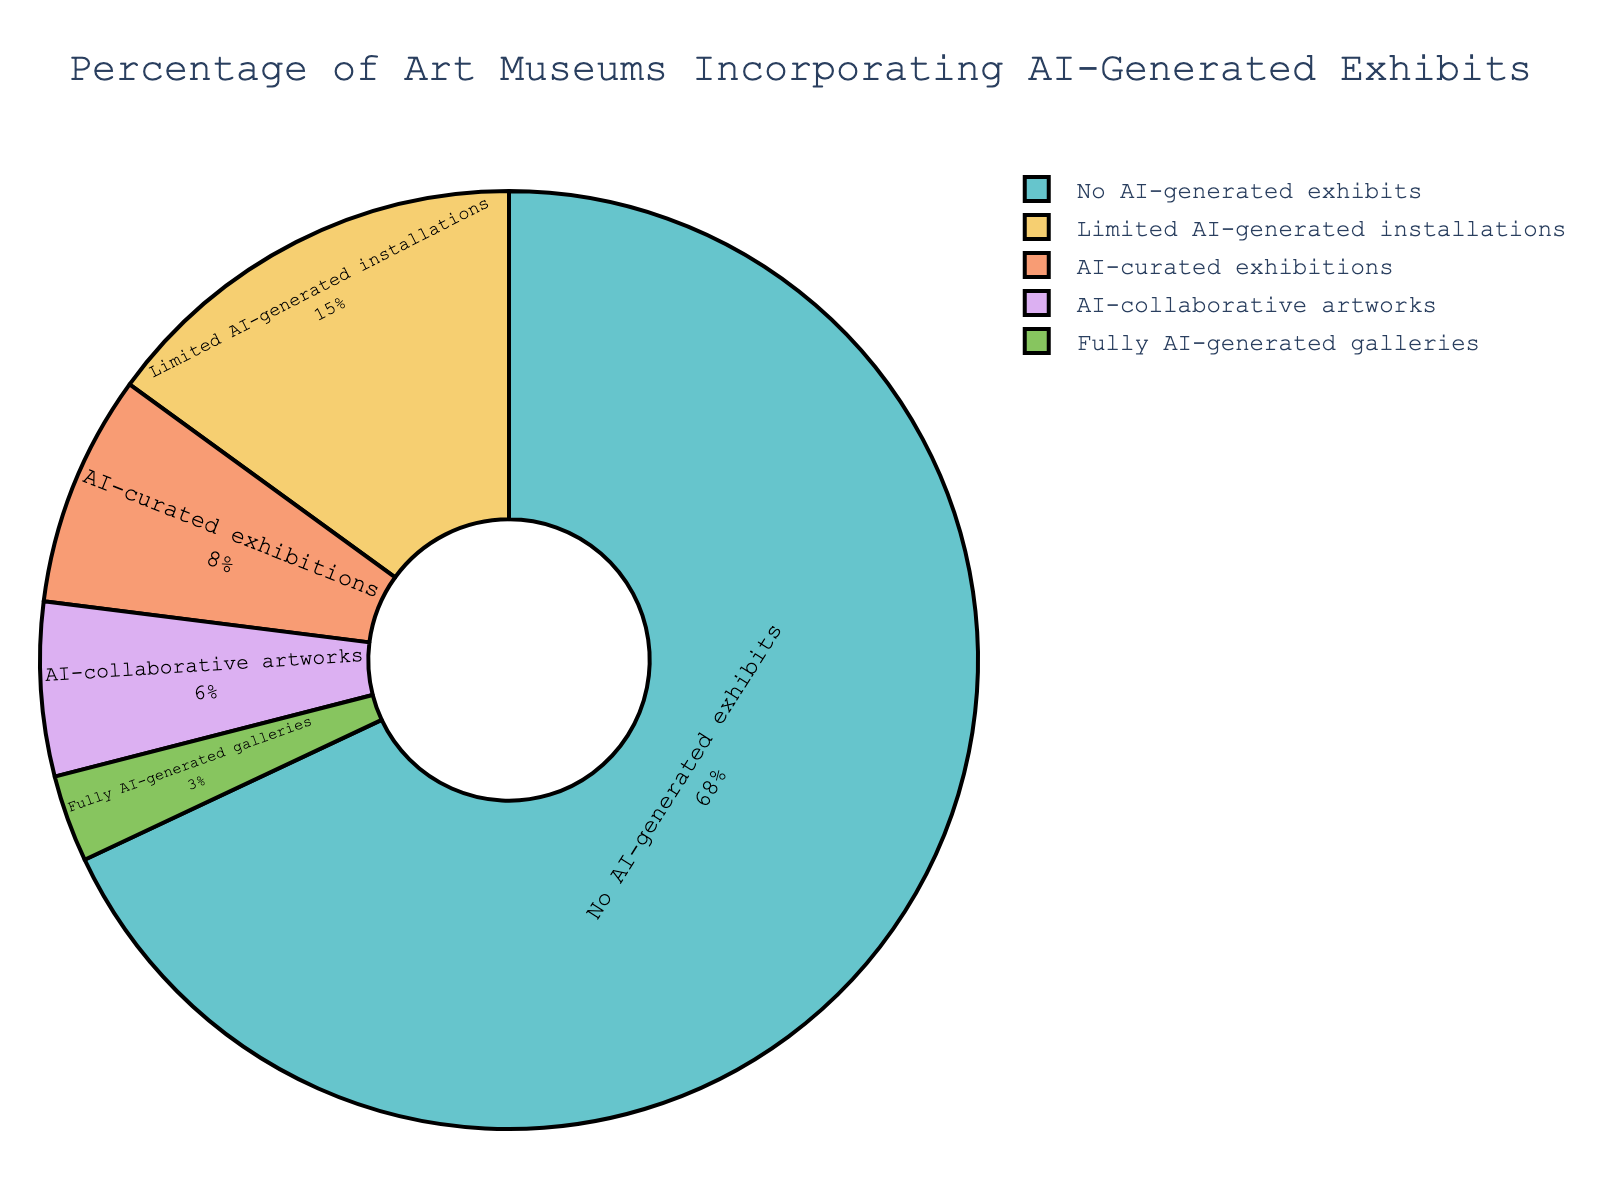Which category encompasses the highest percentage of art museums? The segment labeled "No AI-generated exhibits" is the largest on the pie chart and occupies 68% of the circle's area.
Answer: No AI-generated exhibits What is the combined percentage of museums that have fully AI-generated galleries and those that incorporate AI-collaborative artworks? Summing the percentages of "Fully AI-generated galleries" (3%) and "AI-collaborative artworks" (6%) yields a total percentage. 3% + 6% = 9%.
Answer: 9% How does the percentage of museums with AI-curated exhibitions compare to those with limited AI-generated installations? The percentage of museums with AI-curated exhibitions (8%) is less than that of those with limited AI-generated installations (15%).
Answer: Less Which category of AI incorporation has the lowest percentage among art museums? The segment labeled "Fully AI-generated galleries" occupies the smallest portion of the pie chart, with only 3%.
Answer: Fully AI-generated galleries What is the difference in percentage between museums with no AI-generated exhibits and those with limited AI-generated installations? Subtract the percentage of "Limited AI-generated installations" (15%) from "No AI-generated exhibits" (68%). 68% - 15% = 53%.
Answer: 53% Is there a higher percentage of museums with limited AI-generated installations or AI-collaborative artworks? The segment for "Limited AI-generated installations" is larger at 15%, compared to "AI-collaborative artworks" at 6%.
Answer: Limited AI-generated installations What proportion of the pie chart is represented by all the categories involving AI (from limited installations to fully AI-generated galleries)? Summing the percentages: Limited AI-generated installations (15%) + AI-curated exhibitions (8%) + AI-collaborative artworks (6%) + Fully AI-generated galleries (3%) yields 15% + 8% + 6% + 3% = 32%.
Answer: 32% Which is larger: the combined percentage of AI-curated and AI-collaborative artworks, or the percentage of no AI-generated exhibits? Adding AI-curated exhibitions (8%) and AI-collaborative artworks (6%) gives 14%, which is still less than 68% for no AI-generated exhibits.
Answer: No AI-generated exhibits What's the combined percentage of museums with either no AI exhibits or limited AI installations? Adding the percentages for "No AI-generated exhibits" (68%) and "Limited AI-generated installations" (15%) gives 68% + 15% = 83%.
Answer: 83% 